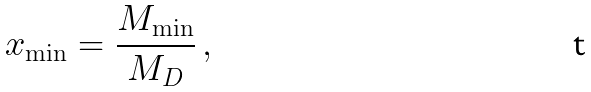<formula> <loc_0><loc_0><loc_500><loc_500>x _ { \min } = \frac { M _ { \min } } { M _ { D } } \, ,</formula> 